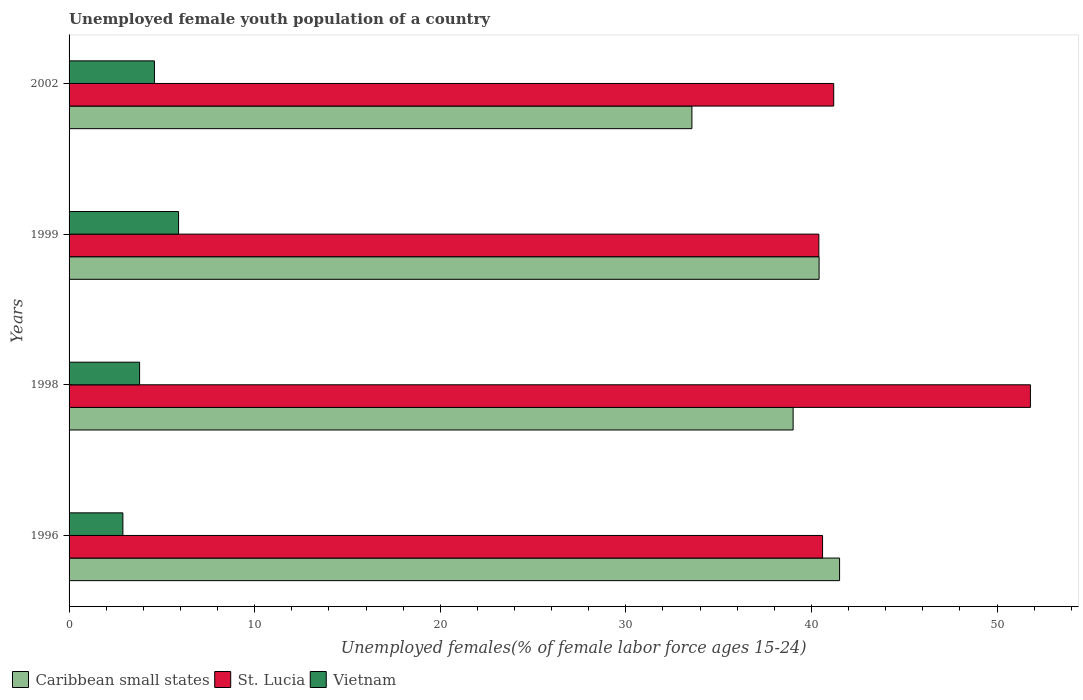How many different coloured bars are there?
Offer a very short reply. 3. Are the number of bars per tick equal to the number of legend labels?
Make the answer very short. Yes. What is the percentage of unemployed female youth population in Caribbean small states in 1998?
Your response must be concise. 39.01. Across all years, what is the maximum percentage of unemployed female youth population in Vietnam?
Keep it short and to the point. 5.9. Across all years, what is the minimum percentage of unemployed female youth population in Caribbean small states?
Ensure brevity in your answer.  33.56. In which year was the percentage of unemployed female youth population in Vietnam minimum?
Offer a terse response. 1996. What is the total percentage of unemployed female youth population in St. Lucia in the graph?
Keep it short and to the point. 174. What is the difference between the percentage of unemployed female youth population in Vietnam in 1999 and that in 2002?
Provide a succinct answer. 1.3. What is the difference between the percentage of unemployed female youth population in Caribbean small states in 1996 and the percentage of unemployed female youth population in Vietnam in 1998?
Keep it short and to the point. 37.72. What is the average percentage of unemployed female youth population in Vietnam per year?
Provide a succinct answer. 4.3. In the year 1996, what is the difference between the percentage of unemployed female youth population in St. Lucia and percentage of unemployed female youth population in Caribbean small states?
Keep it short and to the point. -0.92. In how many years, is the percentage of unemployed female youth population in St. Lucia greater than 4 %?
Make the answer very short. 4. What is the ratio of the percentage of unemployed female youth population in Caribbean small states in 1999 to that in 2002?
Your answer should be very brief. 1.2. Is the percentage of unemployed female youth population in St. Lucia in 1996 less than that in 2002?
Make the answer very short. Yes. Is the difference between the percentage of unemployed female youth population in St. Lucia in 1998 and 2002 greater than the difference between the percentage of unemployed female youth population in Caribbean small states in 1998 and 2002?
Offer a very short reply. Yes. What is the difference between the highest and the second highest percentage of unemployed female youth population in St. Lucia?
Ensure brevity in your answer.  10.6. What is the difference between the highest and the lowest percentage of unemployed female youth population in Caribbean small states?
Provide a short and direct response. 7.96. Is the sum of the percentage of unemployed female youth population in Caribbean small states in 1998 and 2002 greater than the maximum percentage of unemployed female youth population in St. Lucia across all years?
Your response must be concise. Yes. What does the 1st bar from the top in 1998 represents?
Provide a short and direct response. Vietnam. What does the 1st bar from the bottom in 1998 represents?
Your answer should be very brief. Caribbean small states. Is it the case that in every year, the sum of the percentage of unemployed female youth population in Vietnam and percentage of unemployed female youth population in St. Lucia is greater than the percentage of unemployed female youth population in Caribbean small states?
Make the answer very short. Yes. How many years are there in the graph?
Provide a succinct answer. 4. What is the difference between two consecutive major ticks on the X-axis?
Provide a succinct answer. 10. Are the values on the major ticks of X-axis written in scientific E-notation?
Offer a terse response. No. Does the graph contain any zero values?
Provide a succinct answer. No. Where does the legend appear in the graph?
Give a very brief answer. Bottom left. How many legend labels are there?
Your answer should be compact. 3. What is the title of the graph?
Your answer should be very brief. Unemployed female youth population of a country. Does "Sub-Saharan Africa (developing only)" appear as one of the legend labels in the graph?
Keep it short and to the point. No. What is the label or title of the X-axis?
Keep it short and to the point. Unemployed females(% of female labor force ages 15-24). What is the Unemployed females(% of female labor force ages 15-24) of Caribbean small states in 1996?
Make the answer very short. 41.52. What is the Unemployed females(% of female labor force ages 15-24) of St. Lucia in 1996?
Make the answer very short. 40.6. What is the Unemployed females(% of female labor force ages 15-24) in Vietnam in 1996?
Keep it short and to the point. 2.9. What is the Unemployed females(% of female labor force ages 15-24) of Caribbean small states in 1998?
Make the answer very short. 39.01. What is the Unemployed females(% of female labor force ages 15-24) in St. Lucia in 1998?
Offer a very short reply. 51.8. What is the Unemployed females(% of female labor force ages 15-24) in Vietnam in 1998?
Your answer should be very brief. 3.8. What is the Unemployed females(% of female labor force ages 15-24) of Caribbean small states in 1999?
Your answer should be very brief. 40.41. What is the Unemployed females(% of female labor force ages 15-24) of St. Lucia in 1999?
Your answer should be compact. 40.4. What is the Unemployed females(% of female labor force ages 15-24) of Vietnam in 1999?
Provide a succinct answer. 5.9. What is the Unemployed females(% of female labor force ages 15-24) in Caribbean small states in 2002?
Offer a terse response. 33.56. What is the Unemployed females(% of female labor force ages 15-24) of St. Lucia in 2002?
Your answer should be very brief. 41.2. What is the Unemployed females(% of female labor force ages 15-24) in Vietnam in 2002?
Provide a succinct answer. 4.6. Across all years, what is the maximum Unemployed females(% of female labor force ages 15-24) in Caribbean small states?
Offer a very short reply. 41.52. Across all years, what is the maximum Unemployed females(% of female labor force ages 15-24) in St. Lucia?
Provide a succinct answer. 51.8. Across all years, what is the maximum Unemployed females(% of female labor force ages 15-24) in Vietnam?
Keep it short and to the point. 5.9. Across all years, what is the minimum Unemployed females(% of female labor force ages 15-24) of Caribbean small states?
Provide a short and direct response. 33.56. Across all years, what is the minimum Unemployed females(% of female labor force ages 15-24) of St. Lucia?
Your answer should be compact. 40.4. Across all years, what is the minimum Unemployed females(% of female labor force ages 15-24) in Vietnam?
Give a very brief answer. 2.9. What is the total Unemployed females(% of female labor force ages 15-24) of Caribbean small states in the graph?
Your answer should be very brief. 154.5. What is the total Unemployed females(% of female labor force ages 15-24) in St. Lucia in the graph?
Ensure brevity in your answer.  174. What is the difference between the Unemployed females(% of female labor force ages 15-24) of Caribbean small states in 1996 and that in 1998?
Your answer should be very brief. 2.5. What is the difference between the Unemployed females(% of female labor force ages 15-24) of St. Lucia in 1996 and that in 1998?
Offer a terse response. -11.2. What is the difference between the Unemployed females(% of female labor force ages 15-24) of Caribbean small states in 1996 and that in 1999?
Your response must be concise. 1.1. What is the difference between the Unemployed females(% of female labor force ages 15-24) in St. Lucia in 1996 and that in 1999?
Your answer should be compact. 0.2. What is the difference between the Unemployed females(% of female labor force ages 15-24) in Vietnam in 1996 and that in 1999?
Your answer should be very brief. -3. What is the difference between the Unemployed females(% of female labor force ages 15-24) in Caribbean small states in 1996 and that in 2002?
Your answer should be very brief. 7.96. What is the difference between the Unemployed females(% of female labor force ages 15-24) in Vietnam in 1996 and that in 2002?
Offer a very short reply. -1.7. What is the difference between the Unemployed females(% of female labor force ages 15-24) in Caribbean small states in 1998 and that in 1999?
Provide a short and direct response. -1.4. What is the difference between the Unemployed females(% of female labor force ages 15-24) in Caribbean small states in 1998 and that in 2002?
Your answer should be compact. 5.45. What is the difference between the Unemployed females(% of female labor force ages 15-24) of Caribbean small states in 1999 and that in 2002?
Your answer should be very brief. 6.85. What is the difference between the Unemployed females(% of female labor force ages 15-24) in Caribbean small states in 1996 and the Unemployed females(% of female labor force ages 15-24) in St. Lucia in 1998?
Your response must be concise. -10.28. What is the difference between the Unemployed females(% of female labor force ages 15-24) in Caribbean small states in 1996 and the Unemployed females(% of female labor force ages 15-24) in Vietnam in 1998?
Offer a terse response. 37.72. What is the difference between the Unemployed females(% of female labor force ages 15-24) in St. Lucia in 1996 and the Unemployed females(% of female labor force ages 15-24) in Vietnam in 1998?
Provide a succinct answer. 36.8. What is the difference between the Unemployed females(% of female labor force ages 15-24) of Caribbean small states in 1996 and the Unemployed females(% of female labor force ages 15-24) of St. Lucia in 1999?
Provide a succinct answer. 1.12. What is the difference between the Unemployed females(% of female labor force ages 15-24) in Caribbean small states in 1996 and the Unemployed females(% of female labor force ages 15-24) in Vietnam in 1999?
Give a very brief answer. 35.62. What is the difference between the Unemployed females(% of female labor force ages 15-24) in St. Lucia in 1996 and the Unemployed females(% of female labor force ages 15-24) in Vietnam in 1999?
Your response must be concise. 34.7. What is the difference between the Unemployed females(% of female labor force ages 15-24) of Caribbean small states in 1996 and the Unemployed females(% of female labor force ages 15-24) of St. Lucia in 2002?
Keep it short and to the point. 0.32. What is the difference between the Unemployed females(% of female labor force ages 15-24) of Caribbean small states in 1996 and the Unemployed females(% of female labor force ages 15-24) of Vietnam in 2002?
Offer a very short reply. 36.92. What is the difference between the Unemployed females(% of female labor force ages 15-24) of Caribbean small states in 1998 and the Unemployed females(% of female labor force ages 15-24) of St. Lucia in 1999?
Your answer should be very brief. -1.39. What is the difference between the Unemployed females(% of female labor force ages 15-24) of Caribbean small states in 1998 and the Unemployed females(% of female labor force ages 15-24) of Vietnam in 1999?
Offer a very short reply. 33.11. What is the difference between the Unemployed females(% of female labor force ages 15-24) in St. Lucia in 1998 and the Unemployed females(% of female labor force ages 15-24) in Vietnam in 1999?
Make the answer very short. 45.9. What is the difference between the Unemployed females(% of female labor force ages 15-24) in Caribbean small states in 1998 and the Unemployed females(% of female labor force ages 15-24) in St. Lucia in 2002?
Give a very brief answer. -2.19. What is the difference between the Unemployed females(% of female labor force ages 15-24) in Caribbean small states in 1998 and the Unemployed females(% of female labor force ages 15-24) in Vietnam in 2002?
Make the answer very short. 34.41. What is the difference between the Unemployed females(% of female labor force ages 15-24) of St. Lucia in 1998 and the Unemployed females(% of female labor force ages 15-24) of Vietnam in 2002?
Provide a short and direct response. 47.2. What is the difference between the Unemployed females(% of female labor force ages 15-24) of Caribbean small states in 1999 and the Unemployed females(% of female labor force ages 15-24) of St. Lucia in 2002?
Your answer should be very brief. -0.79. What is the difference between the Unemployed females(% of female labor force ages 15-24) in Caribbean small states in 1999 and the Unemployed females(% of female labor force ages 15-24) in Vietnam in 2002?
Ensure brevity in your answer.  35.81. What is the difference between the Unemployed females(% of female labor force ages 15-24) of St. Lucia in 1999 and the Unemployed females(% of female labor force ages 15-24) of Vietnam in 2002?
Keep it short and to the point. 35.8. What is the average Unemployed females(% of female labor force ages 15-24) of Caribbean small states per year?
Keep it short and to the point. 38.63. What is the average Unemployed females(% of female labor force ages 15-24) in St. Lucia per year?
Make the answer very short. 43.5. What is the average Unemployed females(% of female labor force ages 15-24) of Vietnam per year?
Keep it short and to the point. 4.3. In the year 1996, what is the difference between the Unemployed females(% of female labor force ages 15-24) in Caribbean small states and Unemployed females(% of female labor force ages 15-24) in St. Lucia?
Give a very brief answer. 0.92. In the year 1996, what is the difference between the Unemployed females(% of female labor force ages 15-24) of Caribbean small states and Unemployed females(% of female labor force ages 15-24) of Vietnam?
Give a very brief answer. 38.62. In the year 1996, what is the difference between the Unemployed females(% of female labor force ages 15-24) in St. Lucia and Unemployed females(% of female labor force ages 15-24) in Vietnam?
Make the answer very short. 37.7. In the year 1998, what is the difference between the Unemployed females(% of female labor force ages 15-24) of Caribbean small states and Unemployed females(% of female labor force ages 15-24) of St. Lucia?
Offer a terse response. -12.79. In the year 1998, what is the difference between the Unemployed females(% of female labor force ages 15-24) of Caribbean small states and Unemployed females(% of female labor force ages 15-24) of Vietnam?
Make the answer very short. 35.21. In the year 1999, what is the difference between the Unemployed females(% of female labor force ages 15-24) of Caribbean small states and Unemployed females(% of female labor force ages 15-24) of St. Lucia?
Your answer should be compact. 0.01. In the year 1999, what is the difference between the Unemployed females(% of female labor force ages 15-24) of Caribbean small states and Unemployed females(% of female labor force ages 15-24) of Vietnam?
Ensure brevity in your answer.  34.51. In the year 1999, what is the difference between the Unemployed females(% of female labor force ages 15-24) of St. Lucia and Unemployed females(% of female labor force ages 15-24) of Vietnam?
Offer a very short reply. 34.5. In the year 2002, what is the difference between the Unemployed females(% of female labor force ages 15-24) in Caribbean small states and Unemployed females(% of female labor force ages 15-24) in St. Lucia?
Offer a very short reply. -7.64. In the year 2002, what is the difference between the Unemployed females(% of female labor force ages 15-24) of Caribbean small states and Unemployed females(% of female labor force ages 15-24) of Vietnam?
Give a very brief answer. 28.96. In the year 2002, what is the difference between the Unemployed females(% of female labor force ages 15-24) in St. Lucia and Unemployed females(% of female labor force ages 15-24) in Vietnam?
Provide a succinct answer. 36.6. What is the ratio of the Unemployed females(% of female labor force ages 15-24) in Caribbean small states in 1996 to that in 1998?
Offer a terse response. 1.06. What is the ratio of the Unemployed females(% of female labor force ages 15-24) in St. Lucia in 1996 to that in 1998?
Offer a very short reply. 0.78. What is the ratio of the Unemployed females(% of female labor force ages 15-24) of Vietnam in 1996 to that in 1998?
Ensure brevity in your answer.  0.76. What is the ratio of the Unemployed females(% of female labor force ages 15-24) of Caribbean small states in 1996 to that in 1999?
Offer a terse response. 1.03. What is the ratio of the Unemployed females(% of female labor force ages 15-24) in St. Lucia in 1996 to that in 1999?
Offer a terse response. 1. What is the ratio of the Unemployed females(% of female labor force ages 15-24) in Vietnam in 1996 to that in 1999?
Your answer should be compact. 0.49. What is the ratio of the Unemployed females(% of female labor force ages 15-24) of Caribbean small states in 1996 to that in 2002?
Offer a very short reply. 1.24. What is the ratio of the Unemployed females(% of female labor force ages 15-24) in St. Lucia in 1996 to that in 2002?
Give a very brief answer. 0.99. What is the ratio of the Unemployed females(% of female labor force ages 15-24) in Vietnam in 1996 to that in 2002?
Make the answer very short. 0.63. What is the ratio of the Unemployed females(% of female labor force ages 15-24) of Caribbean small states in 1998 to that in 1999?
Provide a succinct answer. 0.97. What is the ratio of the Unemployed females(% of female labor force ages 15-24) in St. Lucia in 1998 to that in 1999?
Keep it short and to the point. 1.28. What is the ratio of the Unemployed females(% of female labor force ages 15-24) in Vietnam in 1998 to that in 1999?
Offer a terse response. 0.64. What is the ratio of the Unemployed females(% of female labor force ages 15-24) in Caribbean small states in 1998 to that in 2002?
Offer a very short reply. 1.16. What is the ratio of the Unemployed females(% of female labor force ages 15-24) in St. Lucia in 1998 to that in 2002?
Give a very brief answer. 1.26. What is the ratio of the Unemployed females(% of female labor force ages 15-24) in Vietnam in 1998 to that in 2002?
Keep it short and to the point. 0.83. What is the ratio of the Unemployed females(% of female labor force ages 15-24) of Caribbean small states in 1999 to that in 2002?
Ensure brevity in your answer.  1.2. What is the ratio of the Unemployed females(% of female labor force ages 15-24) in St. Lucia in 1999 to that in 2002?
Keep it short and to the point. 0.98. What is the ratio of the Unemployed females(% of female labor force ages 15-24) of Vietnam in 1999 to that in 2002?
Provide a succinct answer. 1.28. What is the difference between the highest and the second highest Unemployed females(% of female labor force ages 15-24) of Caribbean small states?
Your response must be concise. 1.1. What is the difference between the highest and the second highest Unemployed females(% of female labor force ages 15-24) of St. Lucia?
Keep it short and to the point. 10.6. What is the difference between the highest and the second highest Unemployed females(% of female labor force ages 15-24) in Vietnam?
Ensure brevity in your answer.  1.3. What is the difference between the highest and the lowest Unemployed females(% of female labor force ages 15-24) of Caribbean small states?
Make the answer very short. 7.96. What is the difference between the highest and the lowest Unemployed females(% of female labor force ages 15-24) in Vietnam?
Your answer should be compact. 3. 